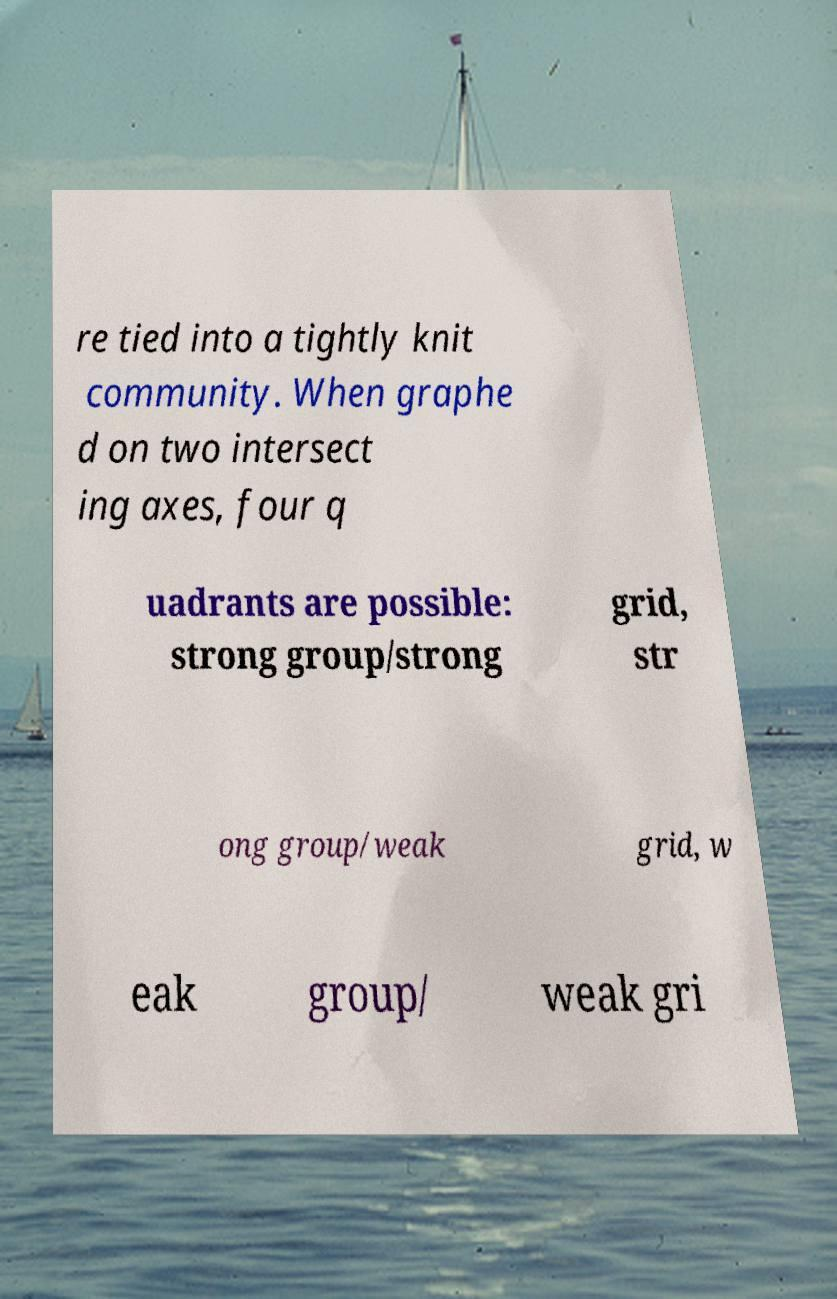Please read and relay the text visible in this image. What does it say? re tied into a tightly knit community. When graphe d on two intersect ing axes, four q uadrants are possible: strong group/strong grid, str ong group/weak grid, w eak group/ weak gri 